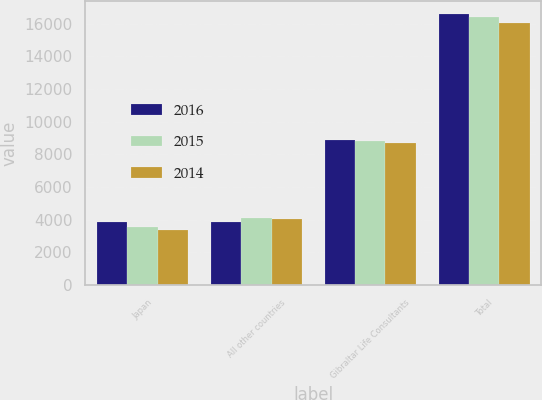Convert chart. <chart><loc_0><loc_0><loc_500><loc_500><stacked_bar_chart><ecel><fcel>Japan<fcel>All other countries<fcel>Gibraltar Life Consultants<fcel>Total<nl><fcel>2016<fcel>3824<fcel>3856<fcel>8884<fcel>16564<nl><fcel>2015<fcel>3528<fcel>4064<fcel>8805<fcel>16397<nl><fcel>2014<fcel>3328<fcel>4024<fcel>8707<fcel>16059<nl></chart> 